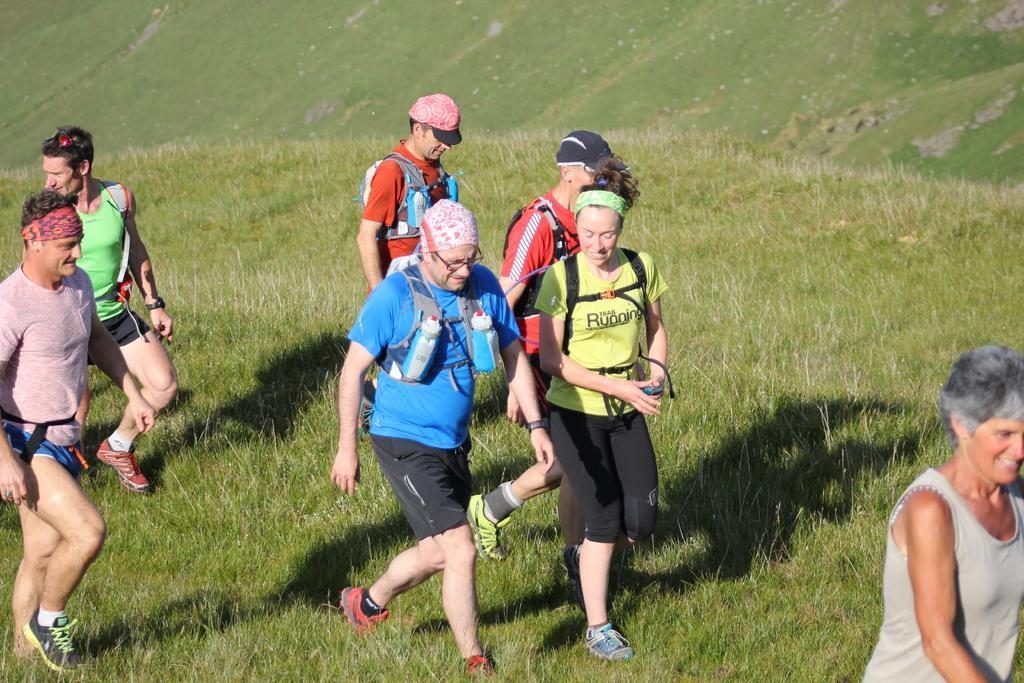In one or two sentences, can you explain what this image depicts? This is an outside view. Here I can see few people wearing bags and walking on the ground towards the right side. On the ground, I can see the grass. 